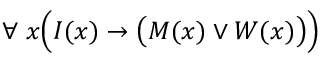<formula> <loc_0><loc_0><loc_500><loc_500>\forall \, x { \left ( } I ( x ) \rightarrow { \left ( } M ( x ) \lor W ( x ) { \right ) } { \right ) }</formula> 